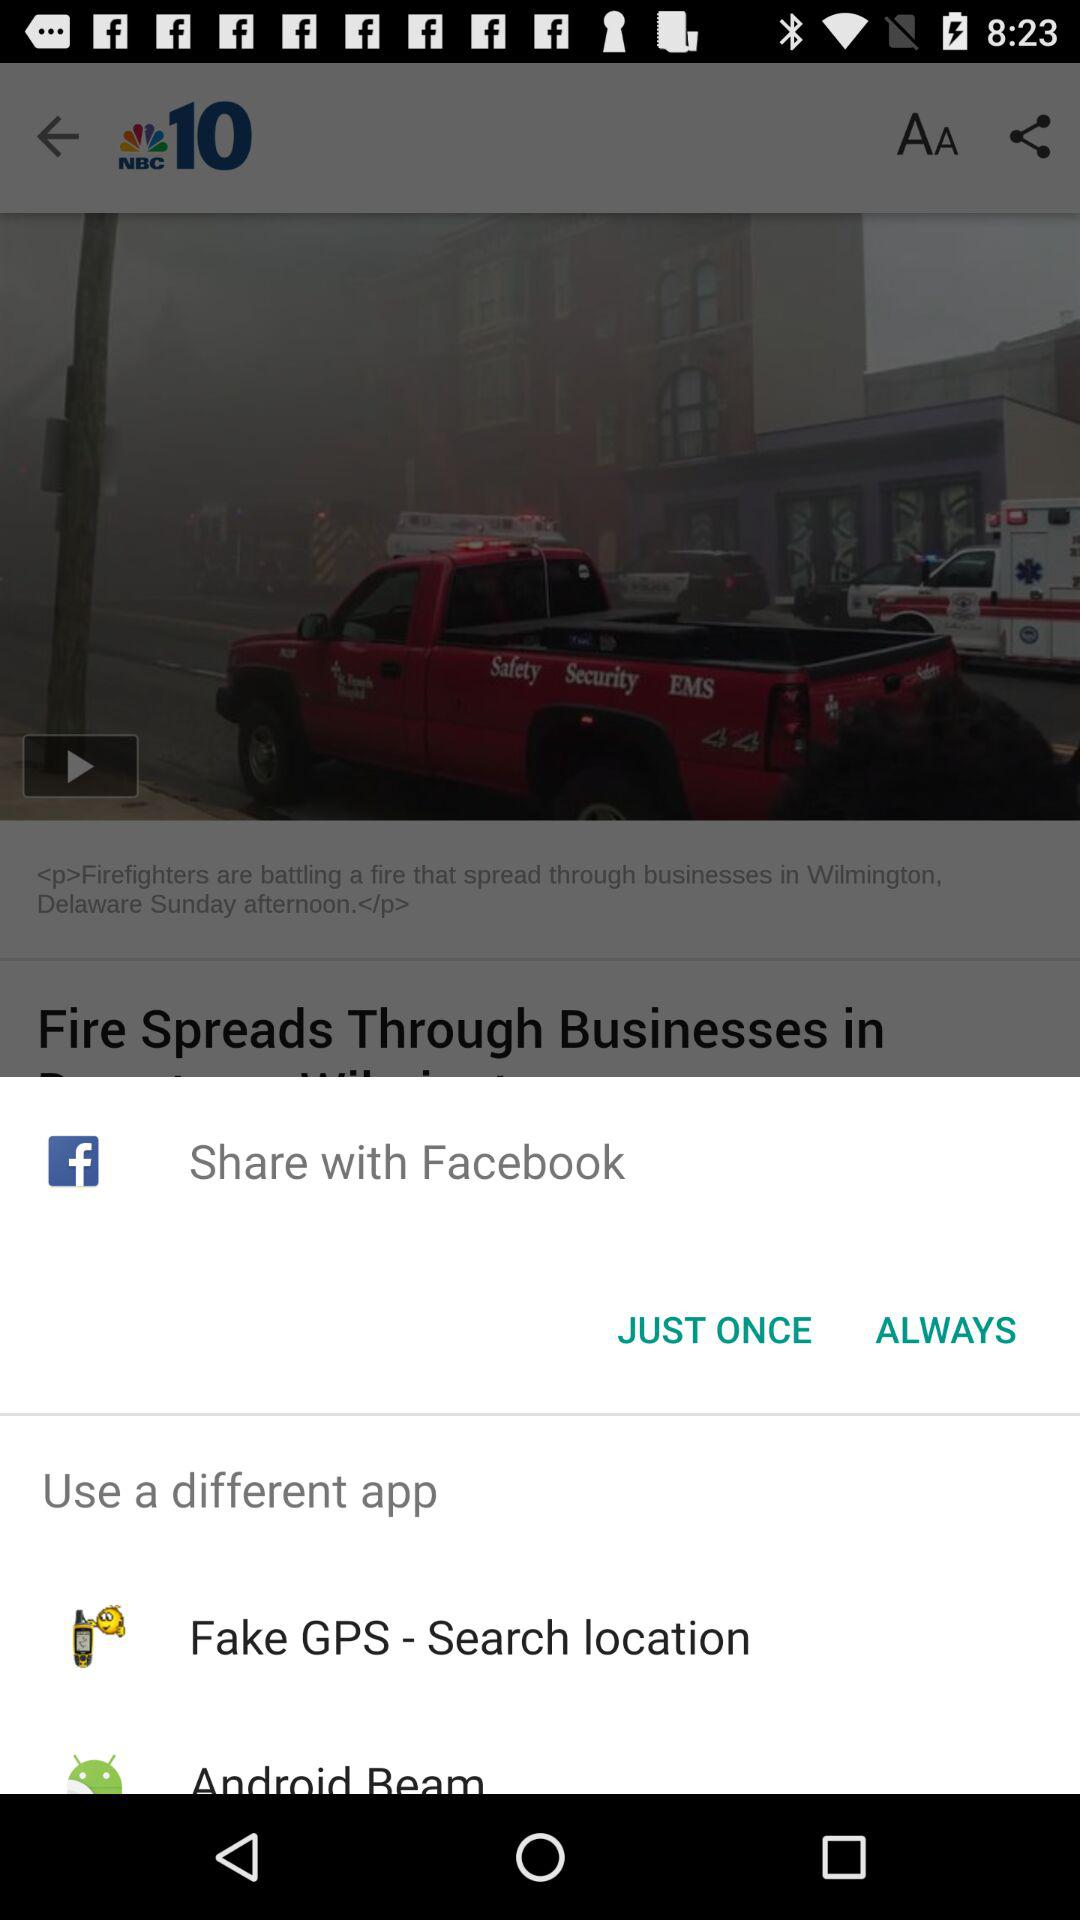What is the name of the application? The name of the application is "NBC10". 